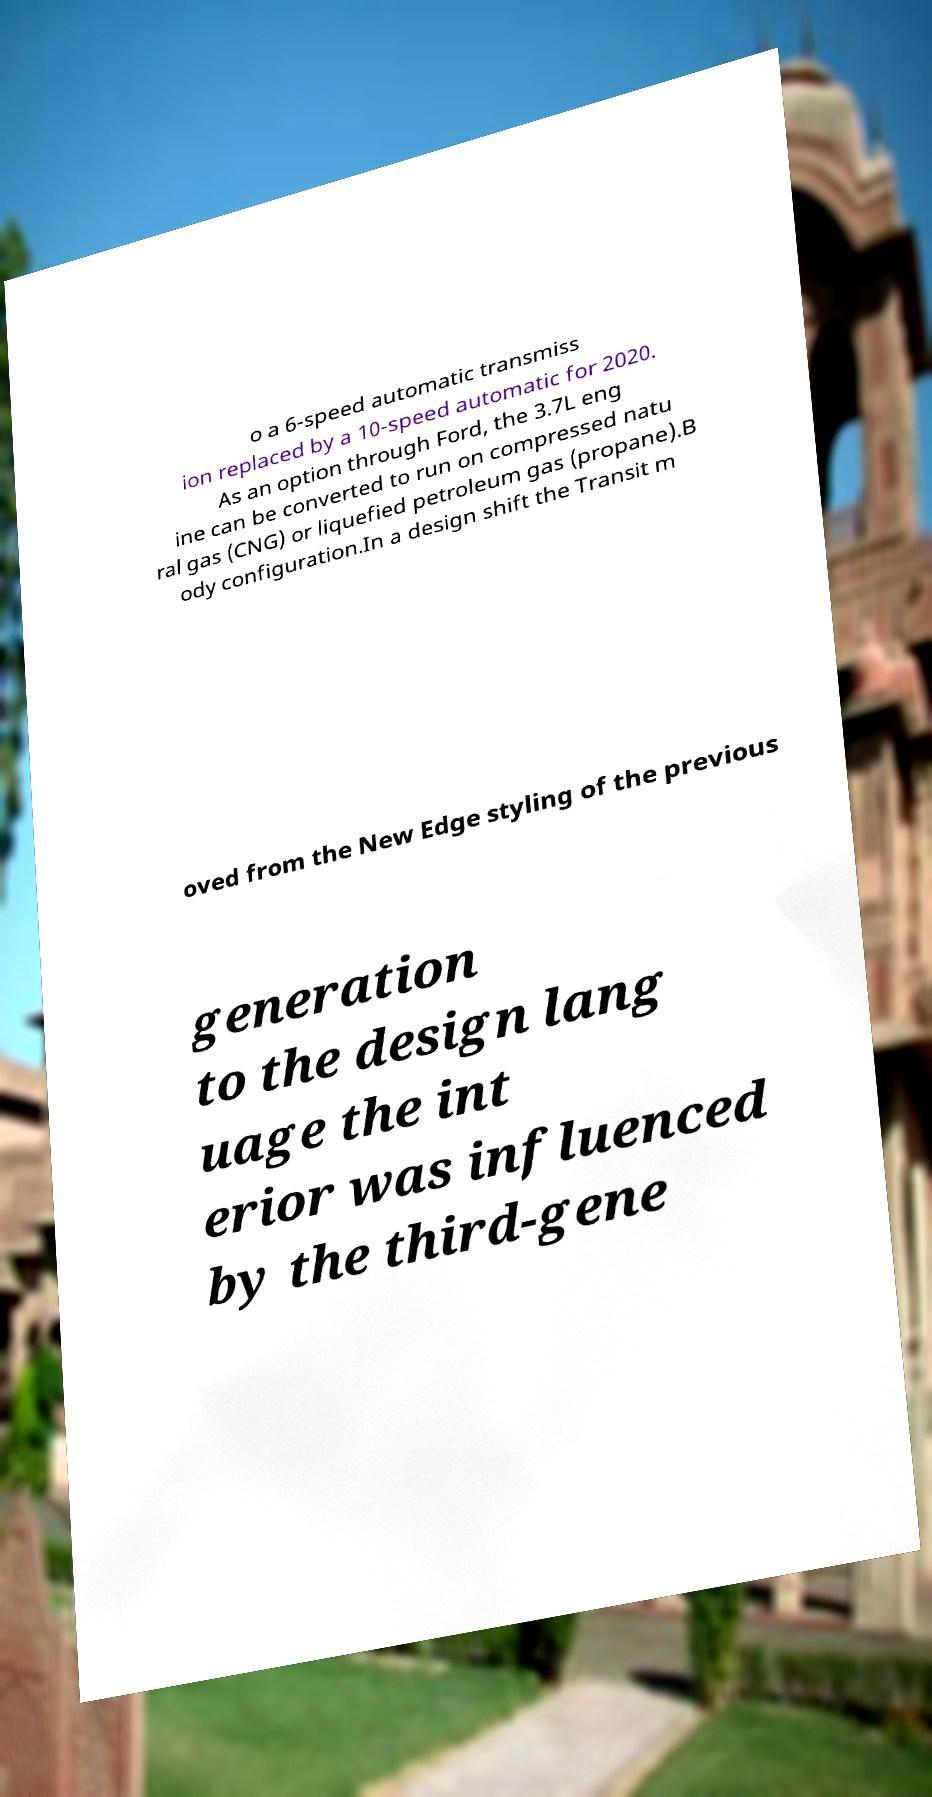I need the written content from this picture converted into text. Can you do that? o a 6-speed automatic transmiss ion replaced by a 10-speed automatic for 2020. As an option through Ford, the 3.7L eng ine can be converted to run on compressed natu ral gas (CNG) or liquefied petroleum gas (propane).B ody configuration.In a design shift the Transit m oved from the New Edge styling of the previous generation to the design lang uage the int erior was influenced by the third-gene 